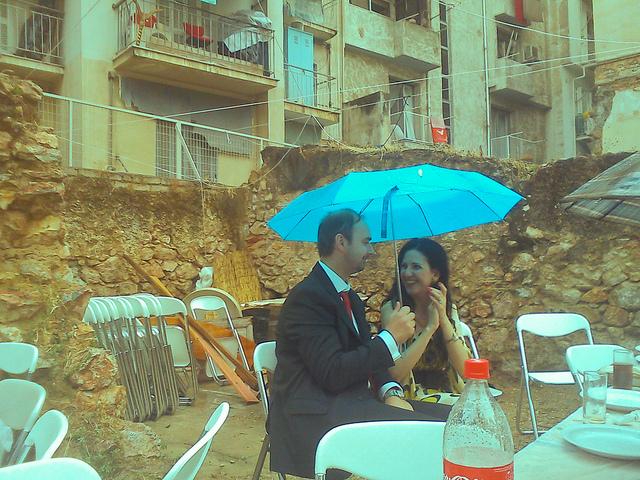What color is the umbrella?
Short answer required. Blue. What is the bottle in the front?
Be succinct. Coke. Are they sitting on folding chairs?
Write a very short answer. Yes. 